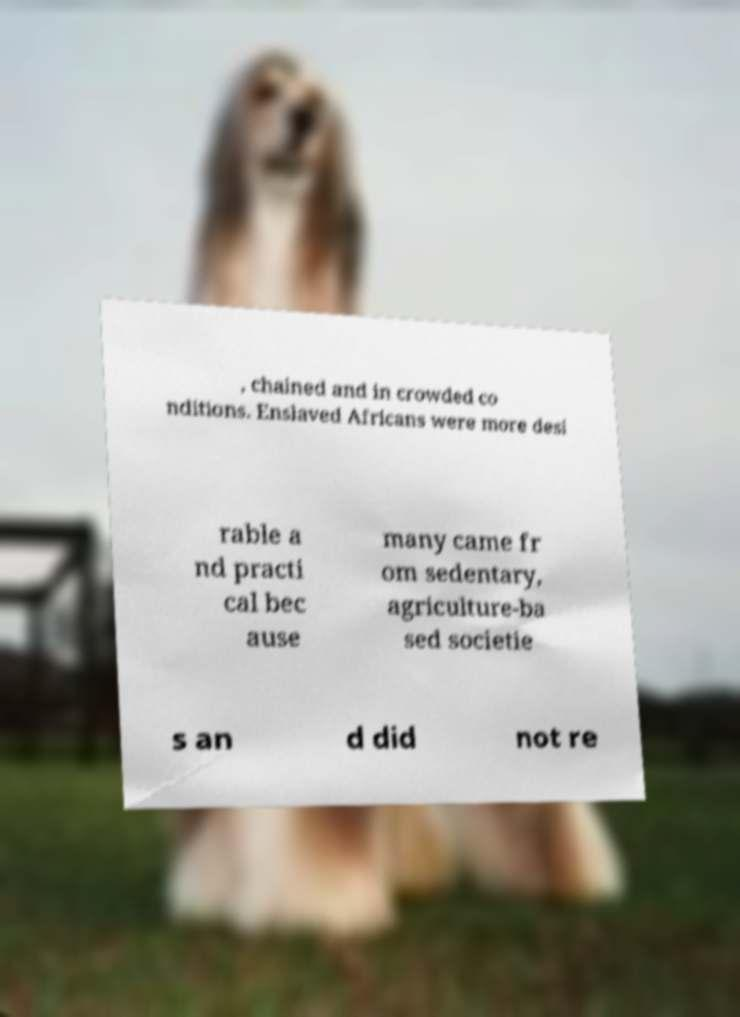Can you accurately transcribe the text from the provided image for me? , chained and in crowded co nditions. Enslaved Africans were more desi rable a nd practi cal bec ause many came fr om sedentary, agriculture-ba sed societie s an d did not re 